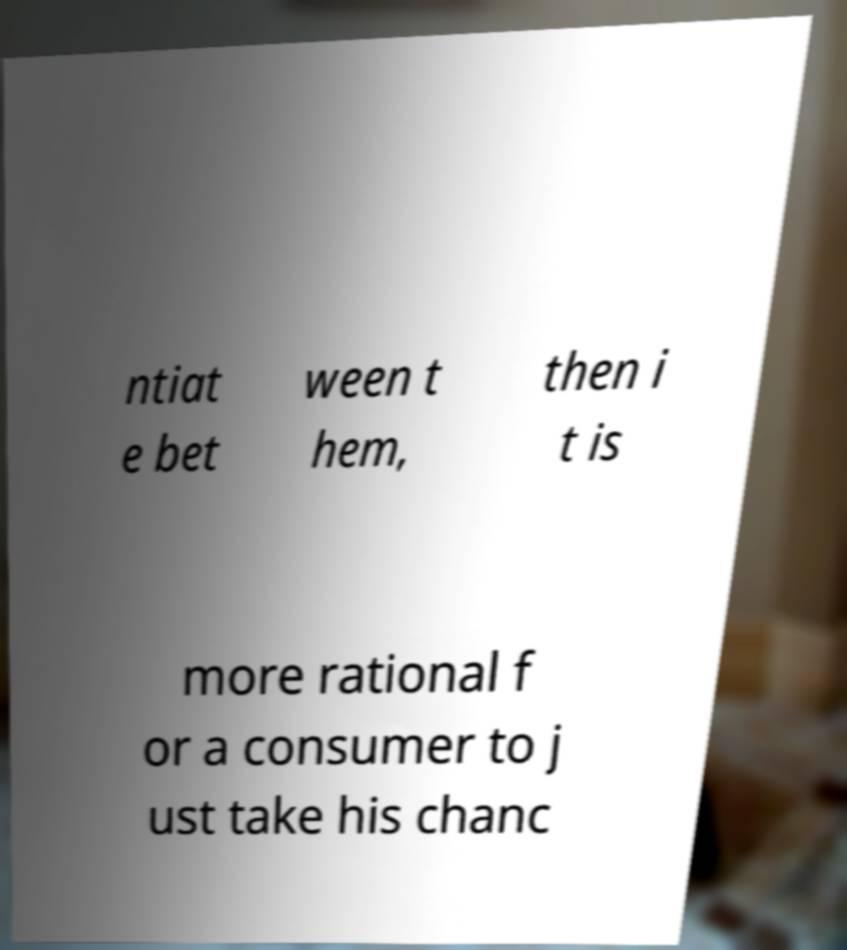Could you assist in decoding the text presented in this image and type it out clearly? ntiat e bet ween t hem, then i t is more rational f or a consumer to j ust take his chanc 